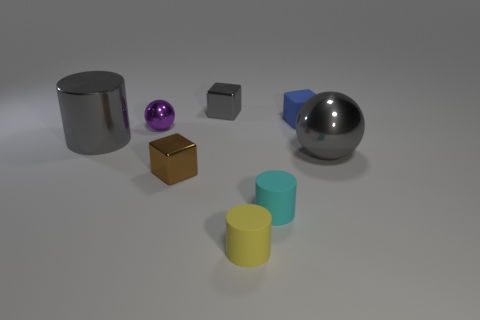How many other objects are the same color as the large metallic cylinder?
Provide a succinct answer. 2. Are there any other things that have the same size as the brown thing?
Provide a succinct answer. Yes. What number of other things are the same shape as the small purple object?
Your answer should be very brief. 1. Does the blue matte cube have the same size as the gray shiny cylinder?
Give a very brief answer. No. Is there a blue object?
Make the answer very short. Yes. Is there anything else that is made of the same material as the small purple ball?
Make the answer very short. Yes. Are there any tiny gray things made of the same material as the small cyan object?
Your response must be concise. No. There is a brown thing that is the same size as the blue matte object; what is it made of?
Offer a very short reply. Metal. What number of other small rubber objects are the same shape as the yellow matte thing?
Provide a succinct answer. 1. There is a gray ball that is made of the same material as the gray cylinder; what size is it?
Offer a terse response. Large. 